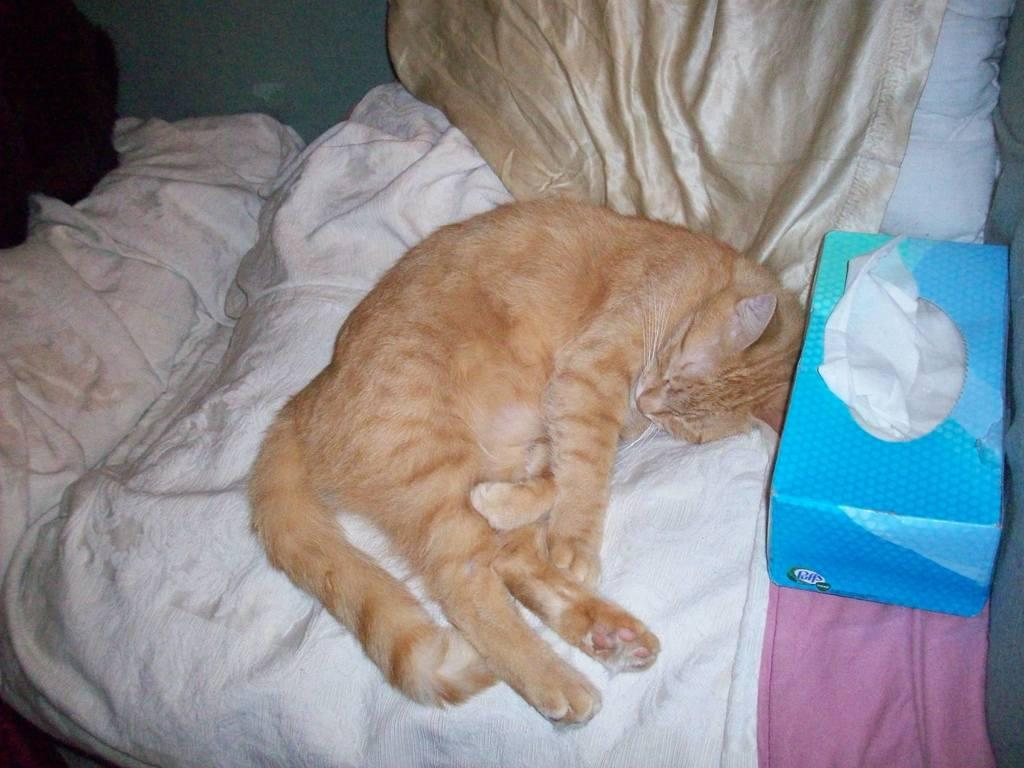What color is the cloth that the cat is sitting on in the image? There is a white cloth in the image, and a cream-colored cat is sitting on it. What other color of cloth is present in the image? There is also a pink cloth in the image. What is the color of the tissue box in the image? The tissue box in the image is blue-colored. Can you describe any other objects in the image besides the cloths and tissue box? There are other unspecified objects in the image, but their details are not provided in the facts. Is there a stick being used as a weapon in the image? There is no mention of a stick or any weapon in the image. The image features a white cloth, a cream-colored cat, a pink cloth, and a blue-colored tissue box, along with unspecified objects. 